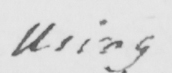Please provide the text content of this handwritten line. Using 